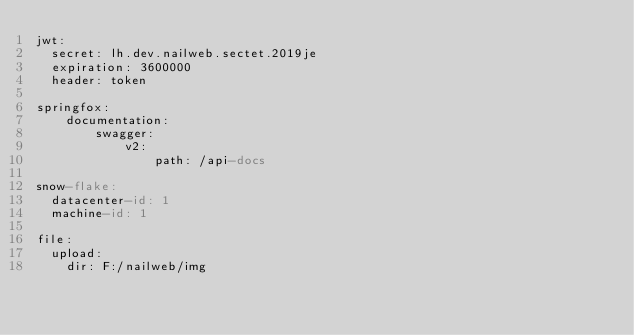<code> <loc_0><loc_0><loc_500><loc_500><_YAML_>jwt:
  secret: lh.dev.nailweb.sectet.2019je
  expiration: 3600000
  header: token

springfox:
    documentation:
        swagger:
            v2:
                path: /api-docs

snow-flake:
  datacenter-id: 1
  machine-id: 1

file:
  upload:
    dir: F:/nailweb/img</code> 